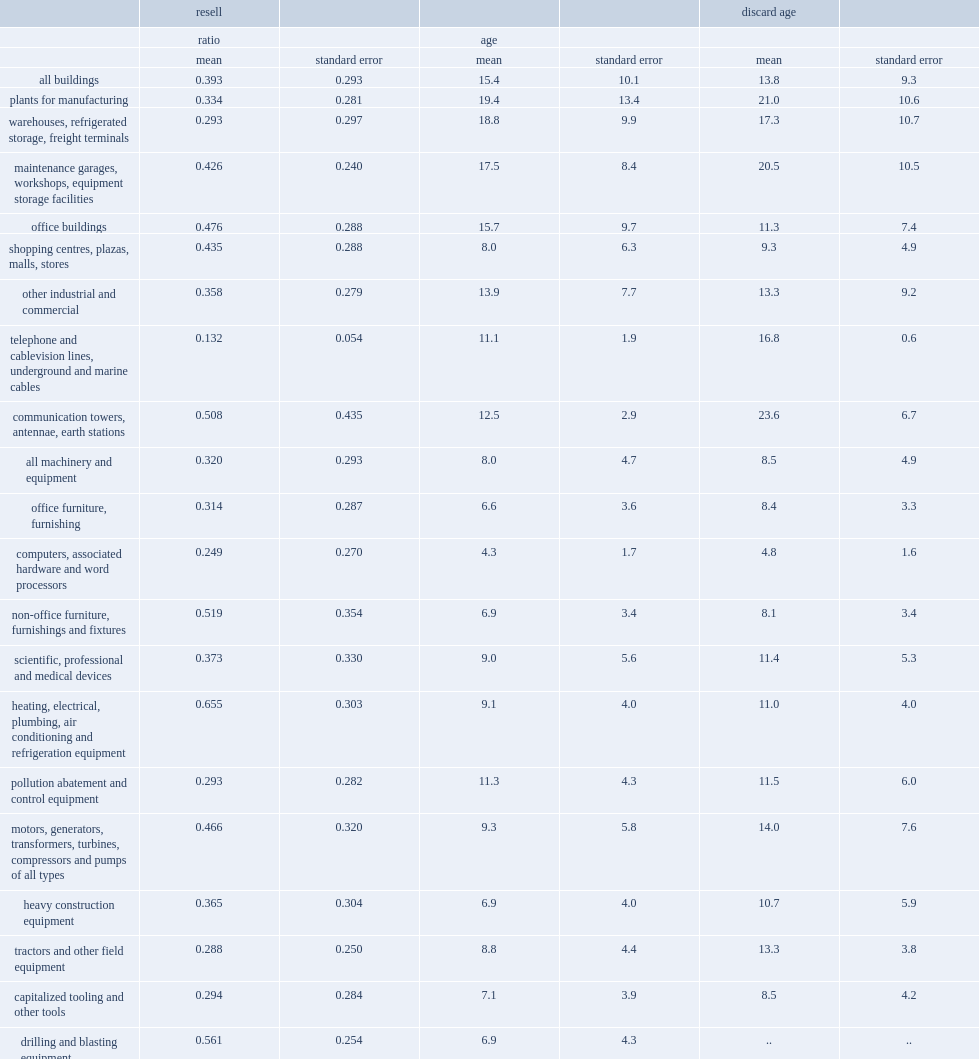From 2002 to 2010, what was the mean reselling price ratio for buildings? 0.393. From 2002 to 2010, what was the mean reselling price ratio for machinery and equipment? 0.32. 